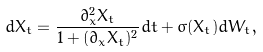<formula> <loc_0><loc_0><loc_500><loc_500>d X _ { t } = \frac { \partial _ { x } ^ { 2 } X _ { t } } { 1 + ( \partial _ { x } X _ { t } ) ^ { 2 } } d t + \sigma ( X _ { t } ) d W _ { t } ,</formula> 